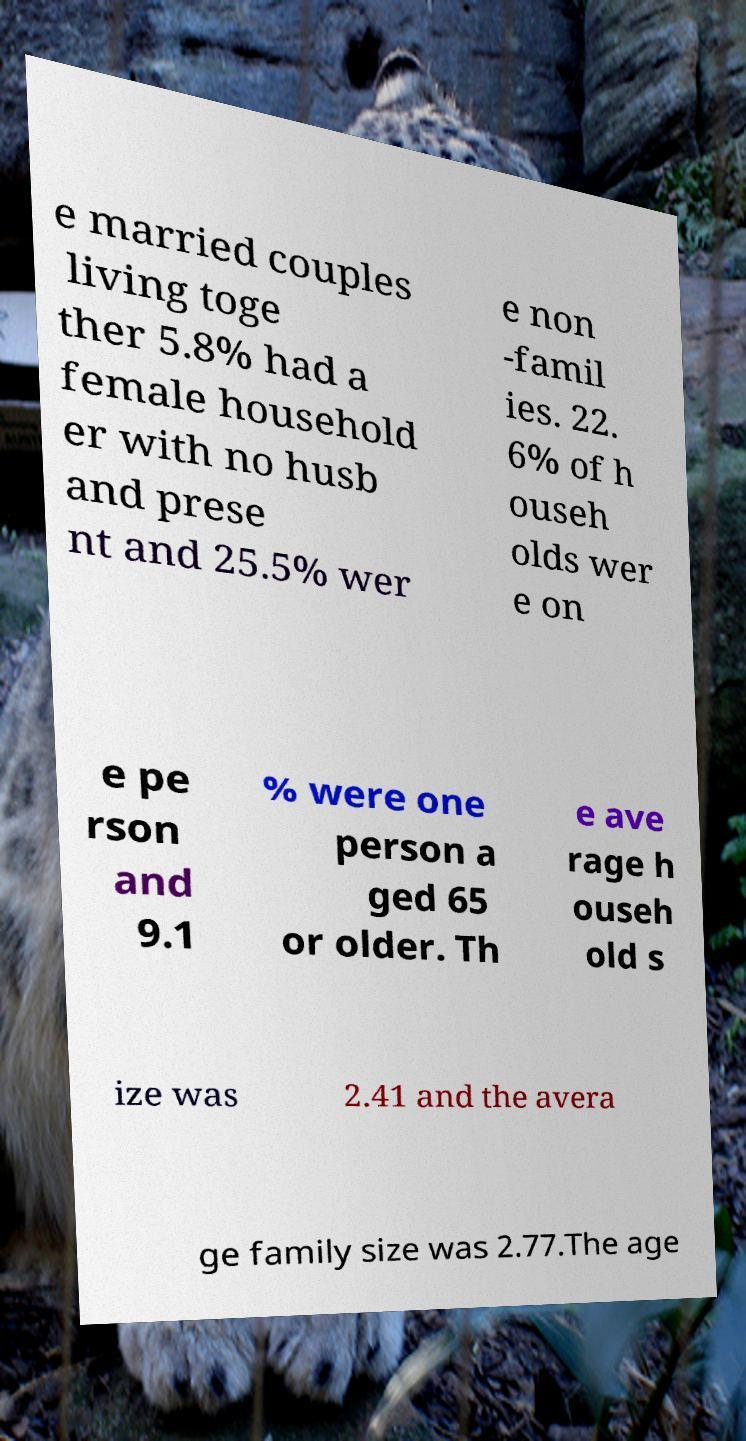Please identify and transcribe the text found in this image. e married couples living toge ther 5.8% had a female household er with no husb and prese nt and 25.5% wer e non -famil ies. 22. 6% of h ouseh olds wer e on e pe rson and 9.1 % were one person a ged 65 or older. Th e ave rage h ouseh old s ize was 2.41 and the avera ge family size was 2.77.The age 